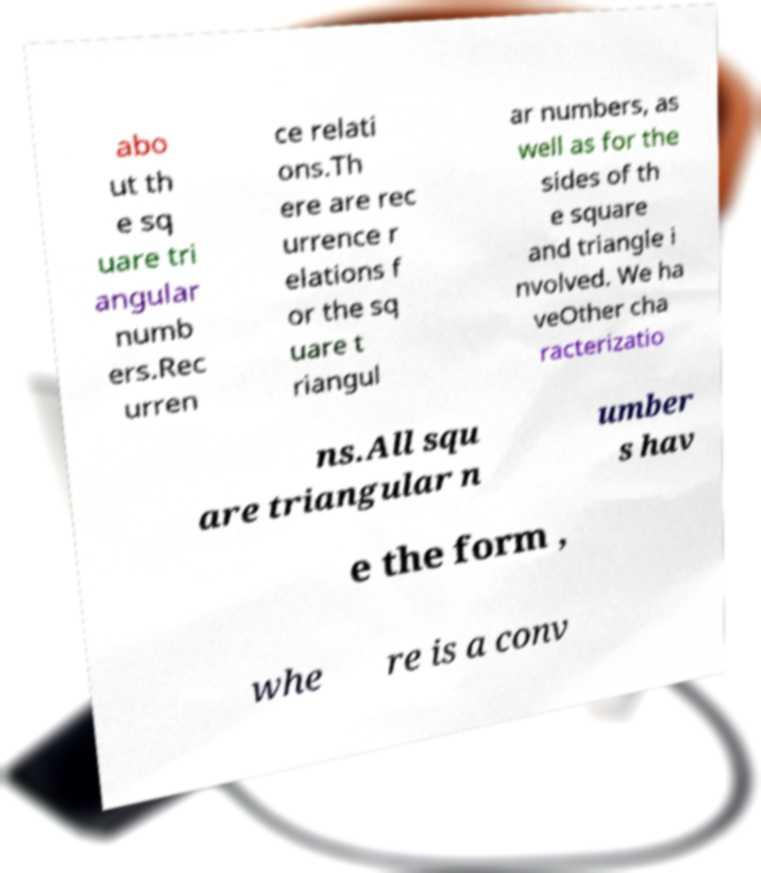I need the written content from this picture converted into text. Can you do that? abo ut th e sq uare tri angular numb ers.Rec urren ce relati ons.Th ere are rec urrence r elations f or the sq uare t riangul ar numbers, as well as for the sides of th e square and triangle i nvolved. We ha veOther cha racterizatio ns.All squ are triangular n umber s hav e the form , whe re is a conv 